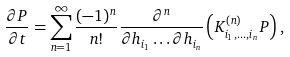Convert formula to latex. <formula><loc_0><loc_0><loc_500><loc_500>\frac { \partial P } { \partial t } = \sum _ { n = 1 } ^ { \infty } \frac { ( - 1 ) ^ { n } } { n ! } \frac { \partial ^ { n } } { \partial h _ { i _ { 1 } } \dots \partial h _ { i _ { n } } } \left ( K ^ { ( n ) } _ { i _ { 1 } , \dots , i _ { n } } P \right ) ,</formula> 